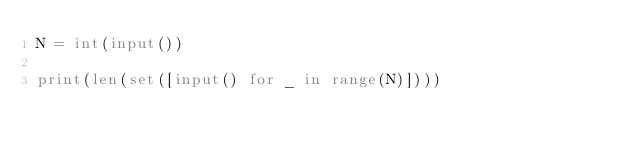Convert code to text. <code><loc_0><loc_0><loc_500><loc_500><_Python_>N = int(input())

print(len(set([input() for _ in range(N)])))</code> 